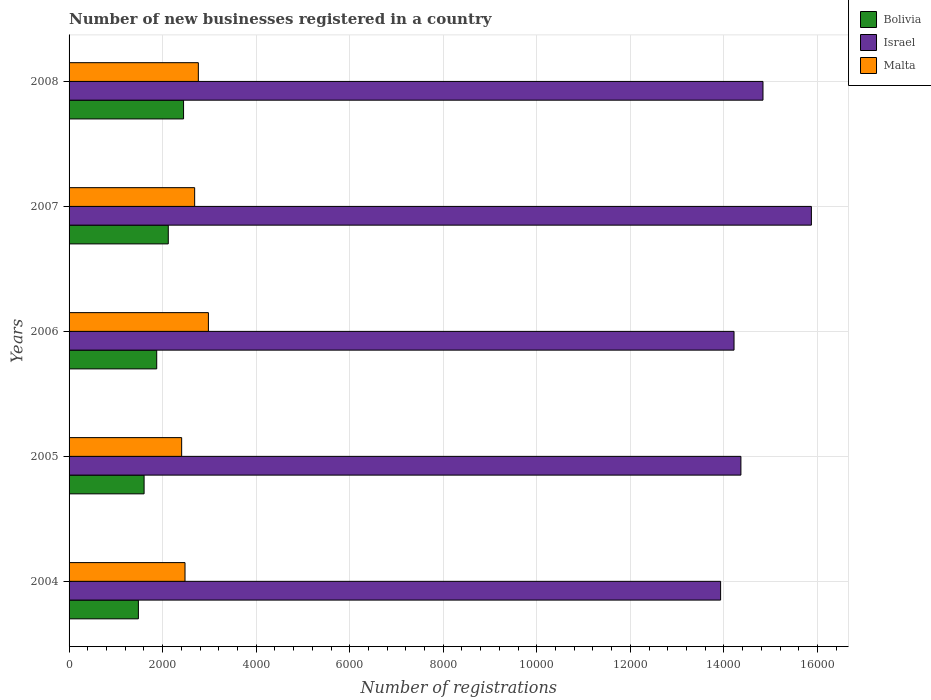How many different coloured bars are there?
Give a very brief answer. 3. Are the number of bars per tick equal to the number of legend labels?
Ensure brevity in your answer.  Yes. Are the number of bars on each tick of the Y-axis equal?
Offer a very short reply. Yes. How many bars are there on the 2nd tick from the top?
Give a very brief answer. 3. In how many cases, is the number of bars for a given year not equal to the number of legend labels?
Keep it short and to the point. 0. What is the number of new businesses registered in Bolivia in 2006?
Provide a succinct answer. 1874. Across all years, what is the maximum number of new businesses registered in Bolivia?
Provide a short and direct response. 2448. Across all years, what is the minimum number of new businesses registered in Malta?
Offer a terse response. 2407. What is the total number of new businesses registered in Israel in the graph?
Make the answer very short. 7.32e+04. What is the difference between the number of new businesses registered in Malta in 2005 and that in 2006?
Provide a short and direct response. -572. What is the difference between the number of new businesses registered in Israel in 2006 and the number of new businesses registered in Bolivia in 2007?
Provide a succinct answer. 1.21e+04. What is the average number of new businesses registered in Israel per year?
Ensure brevity in your answer.  1.46e+04. In the year 2007, what is the difference between the number of new businesses registered in Israel and number of new businesses registered in Malta?
Provide a short and direct response. 1.32e+04. What is the ratio of the number of new businesses registered in Israel in 2004 to that in 2008?
Ensure brevity in your answer.  0.94. Is the number of new businesses registered in Israel in 2007 less than that in 2008?
Offer a very short reply. No. Is the difference between the number of new businesses registered in Israel in 2004 and 2008 greater than the difference between the number of new businesses registered in Malta in 2004 and 2008?
Offer a terse response. No. What is the difference between the highest and the second highest number of new businesses registered in Israel?
Ensure brevity in your answer.  1035. What is the difference between the highest and the lowest number of new businesses registered in Bolivia?
Provide a succinct answer. 966. Is the sum of the number of new businesses registered in Israel in 2006 and 2008 greater than the maximum number of new businesses registered in Malta across all years?
Your answer should be very brief. Yes. What does the 2nd bar from the bottom in 2007 represents?
Ensure brevity in your answer.  Israel. What is the difference between two consecutive major ticks on the X-axis?
Ensure brevity in your answer.  2000. Does the graph contain any zero values?
Give a very brief answer. No. Where does the legend appear in the graph?
Keep it short and to the point. Top right. How many legend labels are there?
Ensure brevity in your answer.  3. How are the legend labels stacked?
Keep it short and to the point. Vertical. What is the title of the graph?
Your response must be concise. Number of new businesses registered in a country. Does "Mauritius" appear as one of the legend labels in the graph?
Ensure brevity in your answer.  No. What is the label or title of the X-axis?
Keep it short and to the point. Number of registrations. What is the label or title of the Y-axis?
Ensure brevity in your answer.  Years. What is the Number of registrations of Bolivia in 2004?
Ensure brevity in your answer.  1482. What is the Number of registrations of Israel in 2004?
Provide a short and direct response. 1.39e+04. What is the Number of registrations of Malta in 2004?
Your answer should be compact. 2479. What is the Number of registrations of Bolivia in 2005?
Make the answer very short. 1604. What is the Number of registrations of Israel in 2005?
Provide a short and direct response. 1.44e+04. What is the Number of registrations of Malta in 2005?
Offer a very short reply. 2407. What is the Number of registrations of Bolivia in 2006?
Your answer should be very brief. 1874. What is the Number of registrations of Israel in 2006?
Make the answer very short. 1.42e+04. What is the Number of registrations of Malta in 2006?
Your answer should be compact. 2979. What is the Number of registrations of Bolivia in 2007?
Provide a succinct answer. 2121. What is the Number of registrations of Israel in 2007?
Keep it short and to the point. 1.59e+04. What is the Number of registrations in Malta in 2007?
Provide a succinct answer. 2685. What is the Number of registrations in Bolivia in 2008?
Keep it short and to the point. 2448. What is the Number of registrations in Israel in 2008?
Ensure brevity in your answer.  1.48e+04. What is the Number of registrations of Malta in 2008?
Offer a terse response. 2764. Across all years, what is the maximum Number of registrations in Bolivia?
Offer a very short reply. 2448. Across all years, what is the maximum Number of registrations of Israel?
Your answer should be compact. 1.59e+04. Across all years, what is the maximum Number of registrations in Malta?
Provide a short and direct response. 2979. Across all years, what is the minimum Number of registrations in Bolivia?
Give a very brief answer. 1482. Across all years, what is the minimum Number of registrations of Israel?
Provide a succinct answer. 1.39e+04. Across all years, what is the minimum Number of registrations of Malta?
Provide a succinct answer. 2407. What is the total Number of registrations of Bolivia in the graph?
Provide a succinct answer. 9529. What is the total Number of registrations in Israel in the graph?
Offer a terse response. 7.32e+04. What is the total Number of registrations in Malta in the graph?
Give a very brief answer. 1.33e+04. What is the difference between the Number of registrations in Bolivia in 2004 and that in 2005?
Offer a terse response. -122. What is the difference between the Number of registrations in Israel in 2004 and that in 2005?
Your response must be concise. -434. What is the difference between the Number of registrations of Bolivia in 2004 and that in 2006?
Provide a succinct answer. -392. What is the difference between the Number of registrations in Israel in 2004 and that in 2006?
Your answer should be very brief. -287. What is the difference between the Number of registrations in Malta in 2004 and that in 2006?
Make the answer very short. -500. What is the difference between the Number of registrations of Bolivia in 2004 and that in 2007?
Your response must be concise. -639. What is the difference between the Number of registrations of Israel in 2004 and that in 2007?
Your response must be concise. -1941. What is the difference between the Number of registrations of Malta in 2004 and that in 2007?
Provide a succinct answer. -206. What is the difference between the Number of registrations of Bolivia in 2004 and that in 2008?
Make the answer very short. -966. What is the difference between the Number of registrations of Israel in 2004 and that in 2008?
Provide a succinct answer. -906. What is the difference between the Number of registrations of Malta in 2004 and that in 2008?
Keep it short and to the point. -285. What is the difference between the Number of registrations in Bolivia in 2005 and that in 2006?
Give a very brief answer. -270. What is the difference between the Number of registrations in Israel in 2005 and that in 2006?
Ensure brevity in your answer.  147. What is the difference between the Number of registrations of Malta in 2005 and that in 2006?
Provide a short and direct response. -572. What is the difference between the Number of registrations of Bolivia in 2005 and that in 2007?
Your answer should be very brief. -517. What is the difference between the Number of registrations in Israel in 2005 and that in 2007?
Make the answer very short. -1507. What is the difference between the Number of registrations in Malta in 2005 and that in 2007?
Keep it short and to the point. -278. What is the difference between the Number of registrations in Bolivia in 2005 and that in 2008?
Your answer should be compact. -844. What is the difference between the Number of registrations of Israel in 2005 and that in 2008?
Your response must be concise. -472. What is the difference between the Number of registrations of Malta in 2005 and that in 2008?
Keep it short and to the point. -357. What is the difference between the Number of registrations in Bolivia in 2006 and that in 2007?
Offer a very short reply. -247. What is the difference between the Number of registrations of Israel in 2006 and that in 2007?
Your answer should be very brief. -1654. What is the difference between the Number of registrations of Malta in 2006 and that in 2007?
Your answer should be very brief. 294. What is the difference between the Number of registrations in Bolivia in 2006 and that in 2008?
Your response must be concise. -574. What is the difference between the Number of registrations of Israel in 2006 and that in 2008?
Your answer should be very brief. -619. What is the difference between the Number of registrations in Malta in 2006 and that in 2008?
Keep it short and to the point. 215. What is the difference between the Number of registrations in Bolivia in 2007 and that in 2008?
Your answer should be compact. -327. What is the difference between the Number of registrations in Israel in 2007 and that in 2008?
Your answer should be very brief. 1035. What is the difference between the Number of registrations of Malta in 2007 and that in 2008?
Keep it short and to the point. -79. What is the difference between the Number of registrations of Bolivia in 2004 and the Number of registrations of Israel in 2005?
Your answer should be very brief. -1.29e+04. What is the difference between the Number of registrations of Bolivia in 2004 and the Number of registrations of Malta in 2005?
Offer a very short reply. -925. What is the difference between the Number of registrations of Israel in 2004 and the Number of registrations of Malta in 2005?
Your response must be concise. 1.15e+04. What is the difference between the Number of registrations of Bolivia in 2004 and the Number of registrations of Israel in 2006?
Your response must be concise. -1.27e+04. What is the difference between the Number of registrations of Bolivia in 2004 and the Number of registrations of Malta in 2006?
Your response must be concise. -1497. What is the difference between the Number of registrations in Israel in 2004 and the Number of registrations in Malta in 2006?
Provide a short and direct response. 1.10e+04. What is the difference between the Number of registrations of Bolivia in 2004 and the Number of registrations of Israel in 2007?
Give a very brief answer. -1.44e+04. What is the difference between the Number of registrations of Bolivia in 2004 and the Number of registrations of Malta in 2007?
Provide a succinct answer. -1203. What is the difference between the Number of registrations of Israel in 2004 and the Number of registrations of Malta in 2007?
Your answer should be compact. 1.12e+04. What is the difference between the Number of registrations of Bolivia in 2004 and the Number of registrations of Israel in 2008?
Your answer should be very brief. -1.34e+04. What is the difference between the Number of registrations in Bolivia in 2004 and the Number of registrations in Malta in 2008?
Provide a short and direct response. -1282. What is the difference between the Number of registrations of Israel in 2004 and the Number of registrations of Malta in 2008?
Your response must be concise. 1.12e+04. What is the difference between the Number of registrations in Bolivia in 2005 and the Number of registrations in Israel in 2006?
Offer a terse response. -1.26e+04. What is the difference between the Number of registrations in Bolivia in 2005 and the Number of registrations in Malta in 2006?
Offer a terse response. -1375. What is the difference between the Number of registrations in Israel in 2005 and the Number of registrations in Malta in 2006?
Give a very brief answer. 1.14e+04. What is the difference between the Number of registrations in Bolivia in 2005 and the Number of registrations in Israel in 2007?
Ensure brevity in your answer.  -1.43e+04. What is the difference between the Number of registrations in Bolivia in 2005 and the Number of registrations in Malta in 2007?
Make the answer very short. -1081. What is the difference between the Number of registrations in Israel in 2005 and the Number of registrations in Malta in 2007?
Ensure brevity in your answer.  1.17e+04. What is the difference between the Number of registrations of Bolivia in 2005 and the Number of registrations of Israel in 2008?
Offer a very short reply. -1.32e+04. What is the difference between the Number of registrations of Bolivia in 2005 and the Number of registrations of Malta in 2008?
Offer a very short reply. -1160. What is the difference between the Number of registrations of Israel in 2005 and the Number of registrations of Malta in 2008?
Provide a succinct answer. 1.16e+04. What is the difference between the Number of registrations in Bolivia in 2006 and the Number of registrations in Israel in 2007?
Your response must be concise. -1.40e+04. What is the difference between the Number of registrations of Bolivia in 2006 and the Number of registrations of Malta in 2007?
Your response must be concise. -811. What is the difference between the Number of registrations of Israel in 2006 and the Number of registrations of Malta in 2007?
Offer a terse response. 1.15e+04. What is the difference between the Number of registrations in Bolivia in 2006 and the Number of registrations in Israel in 2008?
Make the answer very short. -1.30e+04. What is the difference between the Number of registrations in Bolivia in 2006 and the Number of registrations in Malta in 2008?
Offer a terse response. -890. What is the difference between the Number of registrations in Israel in 2006 and the Number of registrations in Malta in 2008?
Keep it short and to the point. 1.15e+04. What is the difference between the Number of registrations of Bolivia in 2007 and the Number of registrations of Israel in 2008?
Your answer should be very brief. -1.27e+04. What is the difference between the Number of registrations of Bolivia in 2007 and the Number of registrations of Malta in 2008?
Provide a short and direct response. -643. What is the difference between the Number of registrations of Israel in 2007 and the Number of registrations of Malta in 2008?
Provide a succinct answer. 1.31e+04. What is the average Number of registrations of Bolivia per year?
Provide a succinct answer. 1905.8. What is the average Number of registrations in Israel per year?
Your response must be concise. 1.46e+04. What is the average Number of registrations of Malta per year?
Offer a very short reply. 2662.8. In the year 2004, what is the difference between the Number of registrations in Bolivia and Number of registrations in Israel?
Ensure brevity in your answer.  -1.24e+04. In the year 2004, what is the difference between the Number of registrations in Bolivia and Number of registrations in Malta?
Ensure brevity in your answer.  -997. In the year 2004, what is the difference between the Number of registrations of Israel and Number of registrations of Malta?
Your answer should be very brief. 1.15e+04. In the year 2005, what is the difference between the Number of registrations in Bolivia and Number of registrations in Israel?
Ensure brevity in your answer.  -1.28e+04. In the year 2005, what is the difference between the Number of registrations of Bolivia and Number of registrations of Malta?
Give a very brief answer. -803. In the year 2005, what is the difference between the Number of registrations in Israel and Number of registrations in Malta?
Offer a terse response. 1.20e+04. In the year 2006, what is the difference between the Number of registrations of Bolivia and Number of registrations of Israel?
Offer a very short reply. -1.23e+04. In the year 2006, what is the difference between the Number of registrations in Bolivia and Number of registrations in Malta?
Offer a very short reply. -1105. In the year 2006, what is the difference between the Number of registrations in Israel and Number of registrations in Malta?
Offer a very short reply. 1.12e+04. In the year 2007, what is the difference between the Number of registrations in Bolivia and Number of registrations in Israel?
Ensure brevity in your answer.  -1.38e+04. In the year 2007, what is the difference between the Number of registrations of Bolivia and Number of registrations of Malta?
Provide a short and direct response. -564. In the year 2007, what is the difference between the Number of registrations of Israel and Number of registrations of Malta?
Ensure brevity in your answer.  1.32e+04. In the year 2008, what is the difference between the Number of registrations of Bolivia and Number of registrations of Israel?
Provide a short and direct response. -1.24e+04. In the year 2008, what is the difference between the Number of registrations of Bolivia and Number of registrations of Malta?
Provide a succinct answer. -316. In the year 2008, what is the difference between the Number of registrations of Israel and Number of registrations of Malta?
Give a very brief answer. 1.21e+04. What is the ratio of the Number of registrations of Bolivia in 2004 to that in 2005?
Make the answer very short. 0.92. What is the ratio of the Number of registrations in Israel in 2004 to that in 2005?
Your answer should be compact. 0.97. What is the ratio of the Number of registrations of Malta in 2004 to that in 2005?
Provide a succinct answer. 1.03. What is the ratio of the Number of registrations in Bolivia in 2004 to that in 2006?
Provide a short and direct response. 0.79. What is the ratio of the Number of registrations in Israel in 2004 to that in 2006?
Make the answer very short. 0.98. What is the ratio of the Number of registrations in Malta in 2004 to that in 2006?
Offer a terse response. 0.83. What is the ratio of the Number of registrations of Bolivia in 2004 to that in 2007?
Your answer should be compact. 0.7. What is the ratio of the Number of registrations of Israel in 2004 to that in 2007?
Provide a short and direct response. 0.88. What is the ratio of the Number of registrations in Malta in 2004 to that in 2007?
Give a very brief answer. 0.92. What is the ratio of the Number of registrations in Bolivia in 2004 to that in 2008?
Your answer should be compact. 0.61. What is the ratio of the Number of registrations in Israel in 2004 to that in 2008?
Your answer should be compact. 0.94. What is the ratio of the Number of registrations of Malta in 2004 to that in 2008?
Your answer should be compact. 0.9. What is the ratio of the Number of registrations in Bolivia in 2005 to that in 2006?
Your answer should be very brief. 0.86. What is the ratio of the Number of registrations of Israel in 2005 to that in 2006?
Give a very brief answer. 1.01. What is the ratio of the Number of registrations in Malta in 2005 to that in 2006?
Keep it short and to the point. 0.81. What is the ratio of the Number of registrations in Bolivia in 2005 to that in 2007?
Keep it short and to the point. 0.76. What is the ratio of the Number of registrations in Israel in 2005 to that in 2007?
Ensure brevity in your answer.  0.91. What is the ratio of the Number of registrations in Malta in 2005 to that in 2007?
Your response must be concise. 0.9. What is the ratio of the Number of registrations of Bolivia in 2005 to that in 2008?
Make the answer very short. 0.66. What is the ratio of the Number of registrations in Israel in 2005 to that in 2008?
Your response must be concise. 0.97. What is the ratio of the Number of registrations of Malta in 2005 to that in 2008?
Provide a succinct answer. 0.87. What is the ratio of the Number of registrations in Bolivia in 2006 to that in 2007?
Offer a terse response. 0.88. What is the ratio of the Number of registrations of Israel in 2006 to that in 2007?
Make the answer very short. 0.9. What is the ratio of the Number of registrations of Malta in 2006 to that in 2007?
Make the answer very short. 1.11. What is the ratio of the Number of registrations of Bolivia in 2006 to that in 2008?
Offer a very short reply. 0.77. What is the ratio of the Number of registrations of Israel in 2006 to that in 2008?
Ensure brevity in your answer.  0.96. What is the ratio of the Number of registrations of Malta in 2006 to that in 2008?
Your answer should be very brief. 1.08. What is the ratio of the Number of registrations in Bolivia in 2007 to that in 2008?
Your response must be concise. 0.87. What is the ratio of the Number of registrations of Israel in 2007 to that in 2008?
Offer a very short reply. 1.07. What is the ratio of the Number of registrations in Malta in 2007 to that in 2008?
Provide a succinct answer. 0.97. What is the difference between the highest and the second highest Number of registrations in Bolivia?
Your answer should be very brief. 327. What is the difference between the highest and the second highest Number of registrations in Israel?
Offer a very short reply. 1035. What is the difference between the highest and the second highest Number of registrations of Malta?
Your answer should be very brief. 215. What is the difference between the highest and the lowest Number of registrations of Bolivia?
Provide a succinct answer. 966. What is the difference between the highest and the lowest Number of registrations in Israel?
Your answer should be very brief. 1941. What is the difference between the highest and the lowest Number of registrations of Malta?
Ensure brevity in your answer.  572. 